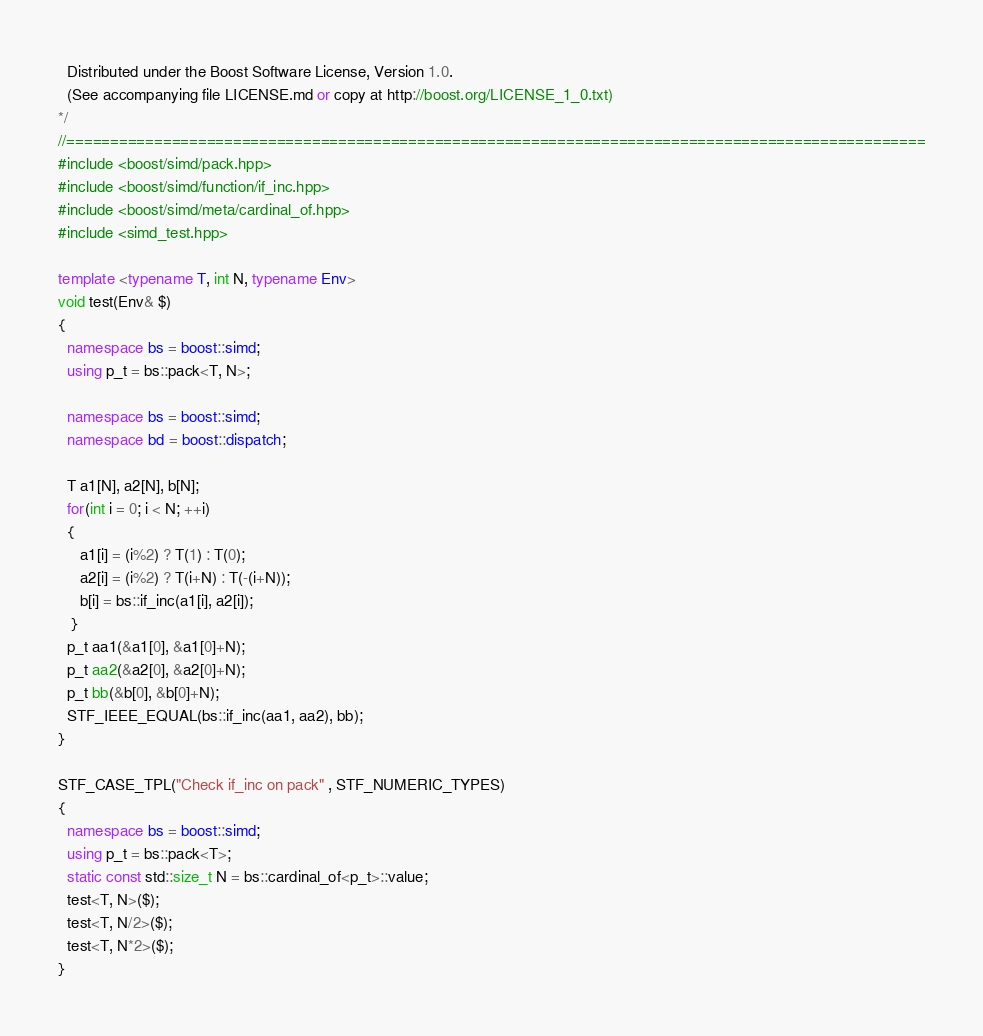<code> <loc_0><loc_0><loc_500><loc_500><_C++_>  Distributed under the Boost Software License, Version 1.0.
  (See accompanying file LICENSE.md or copy at http://boost.org/LICENSE_1_0.txt)
*/
//==================================================================================================
#include <boost/simd/pack.hpp>
#include <boost/simd/function/if_inc.hpp>
#include <boost/simd/meta/cardinal_of.hpp>
#include <simd_test.hpp>

template <typename T, int N, typename Env>
void test(Env& $)
{
  namespace bs = boost::simd;
  using p_t = bs::pack<T, N>;

  namespace bs = boost::simd;
  namespace bd = boost::dispatch;

  T a1[N], a2[N], b[N];
  for(int i = 0; i < N; ++i)
  {
     a1[i] = (i%2) ? T(1) : T(0);
     a2[i] = (i%2) ? T(i+N) : T(-(i+N));
     b[i] = bs::if_inc(a1[i], a2[i]);
   }
  p_t aa1(&a1[0], &a1[0]+N);
  p_t aa2(&a2[0], &a2[0]+N);
  p_t bb(&b[0], &b[0]+N);
  STF_IEEE_EQUAL(bs::if_inc(aa1, aa2), bb);
}

STF_CASE_TPL("Check if_inc on pack" , STF_NUMERIC_TYPES)
{
  namespace bs = boost::simd;
  using p_t = bs::pack<T>;
  static const std::size_t N = bs::cardinal_of<p_t>::value;
  test<T, N>($);
  test<T, N/2>($);
  test<T, N*2>($);
}
</code> 